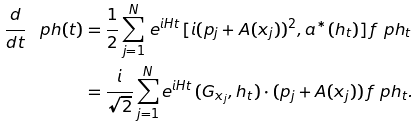Convert formula to latex. <formula><loc_0><loc_0><loc_500><loc_500>\frac { d } { d t } \, \ p h ( t ) & = \frac { 1 } { 2 } \sum _ { j = 1 } ^ { N } \, e ^ { i H t } \, [ i ( p _ { j } + A ( x _ { j } ) ) ^ { 2 } , a ^ { * } ( h _ { t } ) ] \, f \ p h _ { t } \\ & = \frac { i } { \sqrt { 2 } } \sum _ { j = 1 } ^ { N } e ^ { i H t } \, ( G _ { x _ { j } } , h _ { t } ) \cdot ( p _ { j } + A ( x _ { j } ) ) \, f \ p h _ { t } .</formula> 